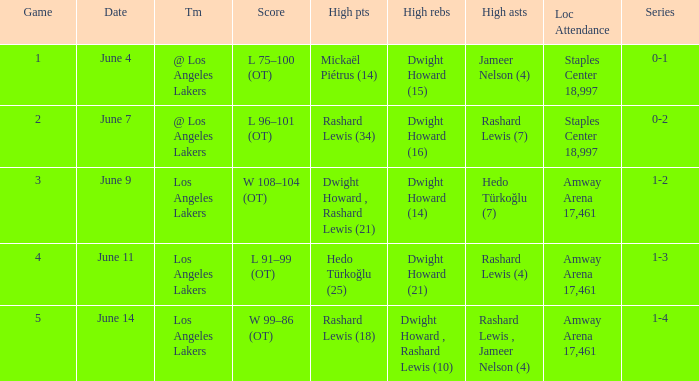With hedo türkoğlu's high assists being 7, what is the maximum game? 3.0. 